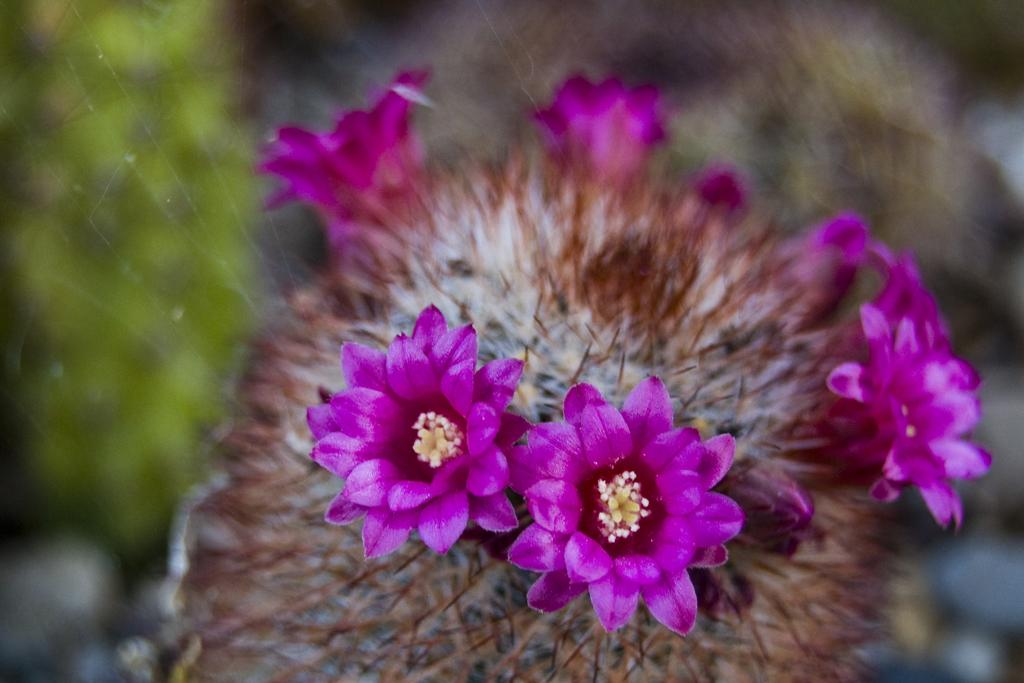What type of flowers can be seen in the image? There are pink flowers in the image. Can you describe the background of the image? The background of the image is blurred. How many ants can be seen crawling on the pin in the image? There are no ants or pins present in the image. 